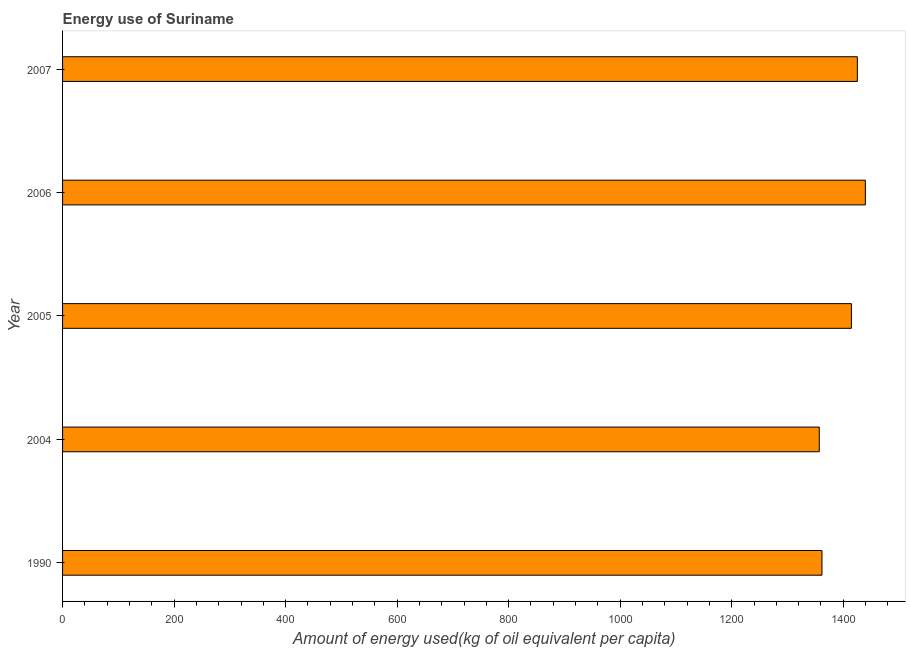Does the graph contain grids?
Your answer should be compact. No. What is the title of the graph?
Offer a very short reply. Energy use of Suriname. What is the label or title of the X-axis?
Your answer should be very brief. Amount of energy used(kg of oil equivalent per capita). What is the amount of energy used in 2004?
Ensure brevity in your answer.  1357.01. Across all years, what is the maximum amount of energy used?
Make the answer very short. 1439.65. Across all years, what is the minimum amount of energy used?
Offer a very short reply. 1357.01. In which year was the amount of energy used minimum?
Ensure brevity in your answer.  2004. What is the sum of the amount of energy used?
Offer a very short reply. 6998.42. What is the difference between the amount of energy used in 2006 and 2007?
Your response must be concise. 14.37. What is the average amount of energy used per year?
Your response must be concise. 1399.68. What is the median amount of energy used?
Make the answer very short. 1414.64. In how many years, is the amount of energy used greater than 40 kg?
Your answer should be compact. 5. What is the ratio of the amount of energy used in 1990 to that in 2006?
Offer a very short reply. 0.95. Is the amount of energy used in 2006 less than that in 2007?
Provide a short and direct response. No. Is the difference between the amount of energy used in 1990 and 2004 greater than the difference between any two years?
Make the answer very short. No. What is the difference between the highest and the second highest amount of energy used?
Offer a very short reply. 14.37. Is the sum of the amount of energy used in 2005 and 2006 greater than the maximum amount of energy used across all years?
Provide a succinct answer. Yes. What is the difference between the highest and the lowest amount of energy used?
Give a very brief answer. 82.65. How many bars are there?
Provide a succinct answer. 5. How many years are there in the graph?
Ensure brevity in your answer.  5. What is the Amount of energy used(kg of oil equivalent per capita) in 1990?
Make the answer very short. 1361.84. What is the Amount of energy used(kg of oil equivalent per capita) of 2004?
Keep it short and to the point. 1357.01. What is the Amount of energy used(kg of oil equivalent per capita) of 2005?
Give a very brief answer. 1414.64. What is the Amount of energy used(kg of oil equivalent per capita) of 2006?
Provide a short and direct response. 1439.65. What is the Amount of energy used(kg of oil equivalent per capita) in 2007?
Your response must be concise. 1425.28. What is the difference between the Amount of energy used(kg of oil equivalent per capita) in 1990 and 2004?
Your answer should be very brief. 4.83. What is the difference between the Amount of energy used(kg of oil equivalent per capita) in 1990 and 2005?
Make the answer very short. -52.8. What is the difference between the Amount of energy used(kg of oil equivalent per capita) in 1990 and 2006?
Ensure brevity in your answer.  -77.82. What is the difference between the Amount of energy used(kg of oil equivalent per capita) in 1990 and 2007?
Keep it short and to the point. -63.45. What is the difference between the Amount of energy used(kg of oil equivalent per capita) in 2004 and 2005?
Your response must be concise. -57.63. What is the difference between the Amount of energy used(kg of oil equivalent per capita) in 2004 and 2006?
Offer a terse response. -82.65. What is the difference between the Amount of energy used(kg of oil equivalent per capita) in 2004 and 2007?
Offer a terse response. -68.28. What is the difference between the Amount of energy used(kg of oil equivalent per capita) in 2005 and 2006?
Offer a very short reply. -25.02. What is the difference between the Amount of energy used(kg of oil equivalent per capita) in 2005 and 2007?
Offer a terse response. -10.65. What is the difference between the Amount of energy used(kg of oil equivalent per capita) in 2006 and 2007?
Keep it short and to the point. 14.37. What is the ratio of the Amount of energy used(kg of oil equivalent per capita) in 1990 to that in 2006?
Offer a very short reply. 0.95. What is the ratio of the Amount of energy used(kg of oil equivalent per capita) in 1990 to that in 2007?
Provide a succinct answer. 0.95. What is the ratio of the Amount of energy used(kg of oil equivalent per capita) in 2004 to that in 2006?
Offer a very short reply. 0.94. What is the ratio of the Amount of energy used(kg of oil equivalent per capita) in 2004 to that in 2007?
Your response must be concise. 0.95. What is the ratio of the Amount of energy used(kg of oil equivalent per capita) in 2005 to that in 2006?
Your answer should be very brief. 0.98. What is the ratio of the Amount of energy used(kg of oil equivalent per capita) in 2005 to that in 2007?
Offer a very short reply. 0.99. 